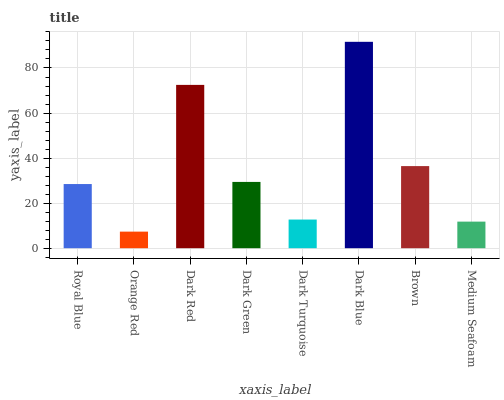Is Dark Red the minimum?
Answer yes or no. No. Is Dark Red the maximum?
Answer yes or no. No. Is Dark Red greater than Orange Red?
Answer yes or no. Yes. Is Orange Red less than Dark Red?
Answer yes or no. Yes. Is Orange Red greater than Dark Red?
Answer yes or no. No. Is Dark Red less than Orange Red?
Answer yes or no. No. Is Dark Green the high median?
Answer yes or no. Yes. Is Royal Blue the low median?
Answer yes or no. Yes. Is Orange Red the high median?
Answer yes or no. No. Is Dark Red the low median?
Answer yes or no. No. 